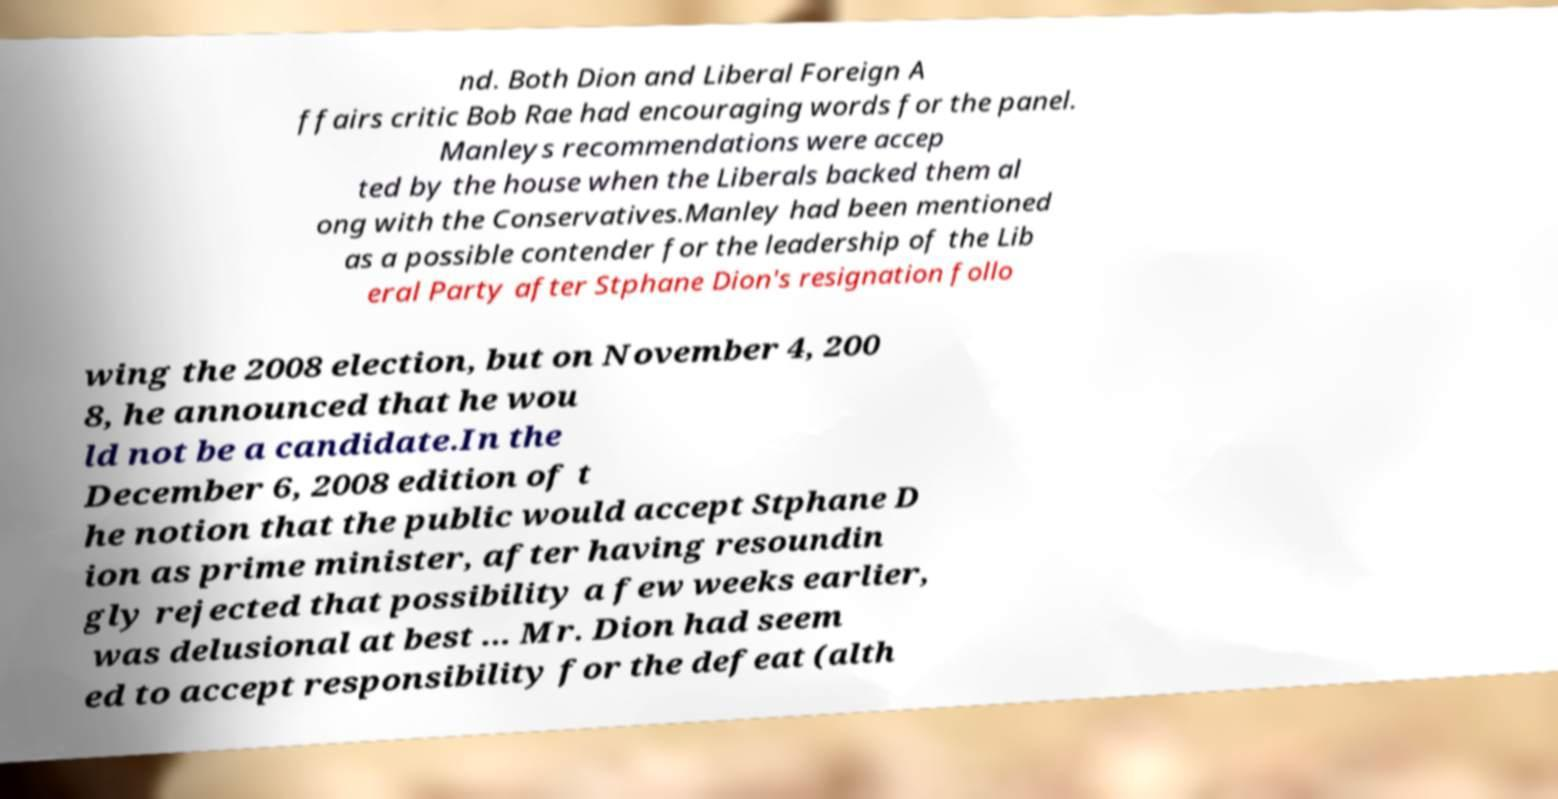Can you accurately transcribe the text from the provided image for me? nd. Both Dion and Liberal Foreign A ffairs critic Bob Rae had encouraging words for the panel. Manleys recommendations were accep ted by the house when the Liberals backed them al ong with the Conservatives.Manley had been mentioned as a possible contender for the leadership of the Lib eral Party after Stphane Dion's resignation follo wing the 2008 election, but on November 4, 200 8, he announced that he wou ld not be a candidate.In the December 6, 2008 edition of t he notion that the public would accept Stphane D ion as prime minister, after having resoundin gly rejected that possibility a few weeks earlier, was delusional at best ... Mr. Dion had seem ed to accept responsibility for the defeat (alth 